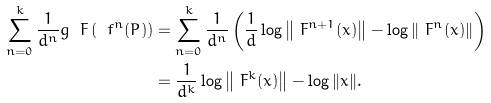Convert formula to latex. <formula><loc_0><loc_0><loc_500><loc_500>\sum _ { n = 0 } ^ { k } \frac { 1 } { d ^ { n } } g _ { \ } F \left ( \ f ^ { n } ( P ) \right ) & = \sum _ { n = 0 } ^ { k } \frac { 1 } { d ^ { n } } \left ( \frac { 1 } { d } \log \left \| \ F ^ { n + 1 } ( x ) \right \| - \log \left \| \ F ^ { n } ( x ) \right \| \right ) \\ & = \frac { 1 } { d ^ { k } } \log \left \| \ F ^ { k } ( x ) \right \| - \log \| x \| .</formula> 